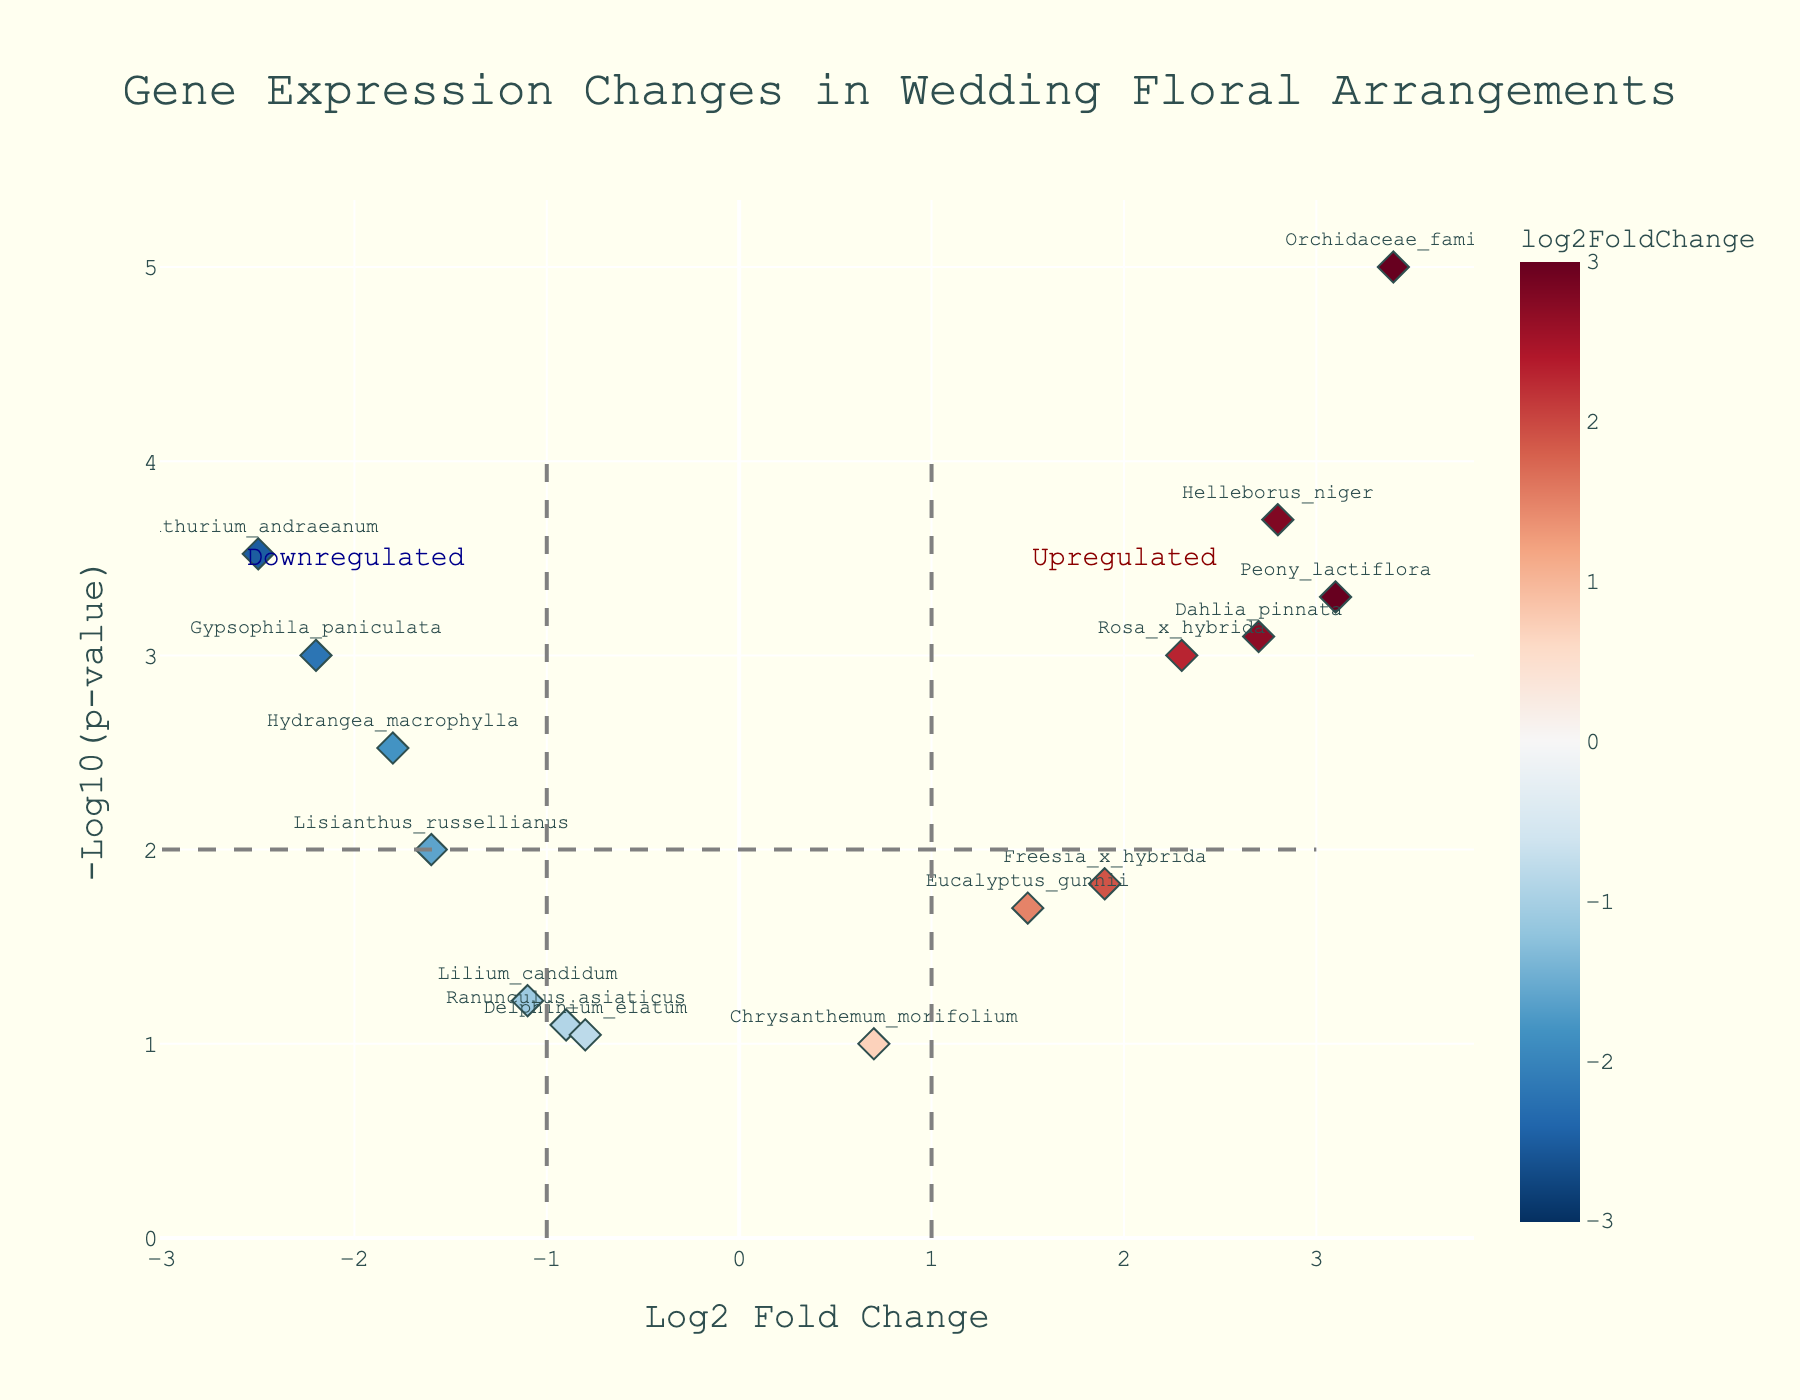what's the title of the plot? The title of the plot is displayed prominently at the top center of the figure.
Answer: Gene Expression Changes in Wedding Floral Arrangements how many genes are upregulated significantly (with p-value < 0.05)? Count the data points with positive log2FoldChange and -log10(pValue) greater than 1.3 (since -log10(0.05) ≈ 1.3).
Answer: 7 which gene has the highest log2 fold change? Identify the data point farthest to the right on the x-axis.
Answer: Orchidaceae_family what's the log2FoldChange and p-value for Dahlia_pinnata? Locate Dahlia_pinnata among the data points, the hover data reveals the values.
Answer: 2.7 and 0.0008 which gene is the most downregulated? Identify the data point farthest to the left on the x-axis.
Answer: Anthurium_andraeanum how many genes lie in the non-significant region (p-value ≥ 0.05)? Count the data points with -log10(pValue) less than 1.3.
Answer: 4 which genes are both highly upregulated and have a p-value < 0.001? Count the data points in the upper right quadrant with -log10(pValue) greater than 3.
Answer: Orchidaceae_family, Peony_lactiflora, Helleborus_niger are there more downregulated or upregulated genes with p-value < 0.01? Count the genes with negative and positive log2FoldChange values, separately, having -log10(pValue) greater than 2.
Answer: More upregulated what's the range of log2 fold change depicted in the plot? Identify the minimum and maximum values on the x-axis.
Answer: -2.5 to 3.4 what's the significance threshold in terms of -log10(p-value) and how is it visually represented? The significance threshold is at -log10(pValue) = 2, represented by a grey dashed line across the plot.
Answer: 2 